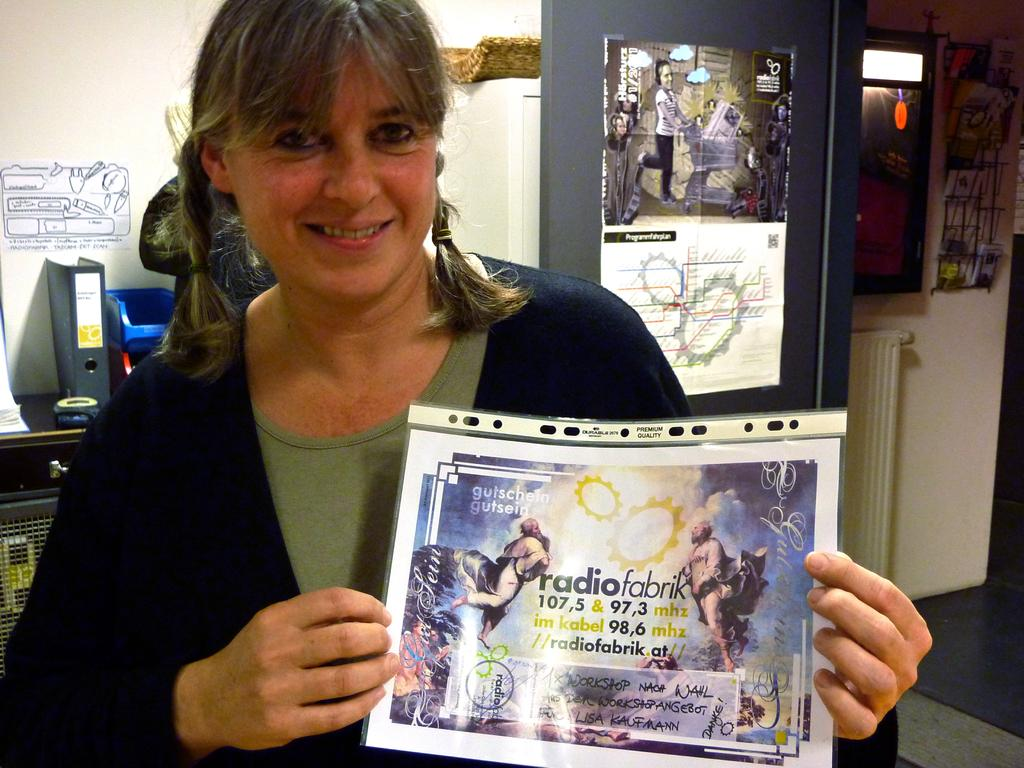<image>
Relay a brief, clear account of the picture shown. A woman is holding a poster that says radio fabrik. 